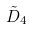<formula> <loc_0><loc_0><loc_500><loc_500>\tilde { D } _ { 4 }</formula> 